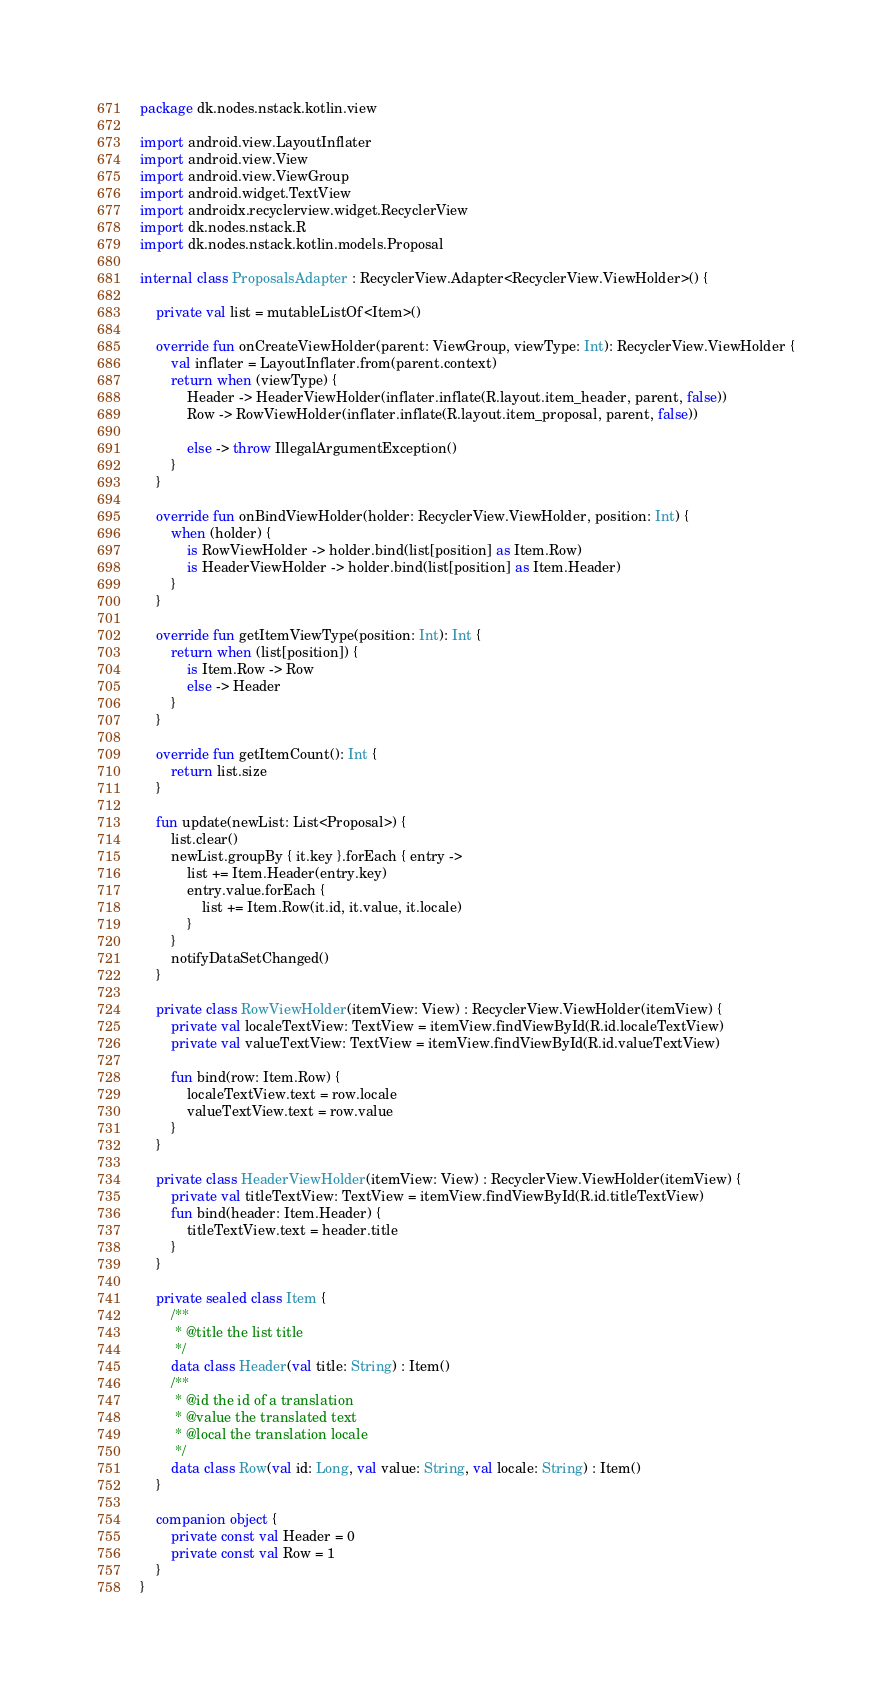Convert code to text. <code><loc_0><loc_0><loc_500><loc_500><_Kotlin_>package dk.nodes.nstack.kotlin.view

import android.view.LayoutInflater
import android.view.View
import android.view.ViewGroup
import android.widget.TextView
import androidx.recyclerview.widget.RecyclerView
import dk.nodes.nstack.R
import dk.nodes.nstack.kotlin.models.Proposal

internal class ProposalsAdapter : RecyclerView.Adapter<RecyclerView.ViewHolder>() {

    private val list = mutableListOf<Item>()

    override fun onCreateViewHolder(parent: ViewGroup, viewType: Int): RecyclerView.ViewHolder {
        val inflater = LayoutInflater.from(parent.context)
        return when (viewType) {
            Header -> HeaderViewHolder(inflater.inflate(R.layout.item_header, parent, false))
            Row -> RowViewHolder(inflater.inflate(R.layout.item_proposal, parent, false))

            else -> throw IllegalArgumentException()
        }
    }

    override fun onBindViewHolder(holder: RecyclerView.ViewHolder, position: Int) {
        when (holder) {
            is RowViewHolder -> holder.bind(list[position] as Item.Row)
            is HeaderViewHolder -> holder.bind(list[position] as Item.Header)
        }
    }

    override fun getItemViewType(position: Int): Int {
        return when (list[position]) {
            is Item.Row -> Row
            else -> Header
        }
    }

    override fun getItemCount(): Int {
        return list.size
    }

    fun update(newList: List<Proposal>) {
        list.clear()
        newList.groupBy { it.key }.forEach { entry ->
            list += Item.Header(entry.key)
            entry.value.forEach {
                list += Item.Row(it.id, it.value, it.locale)
            }
        }
        notifyDataSetChanged()
    }

    private class RowViewHolder(itemView: View) : RecyclerView.ViewHolder(itemView) {
        private val localeTextView: TextView = itemView.findViewById(R.id.localeTextView)
        private val valueTextView: TextView = itemView.findViewById(R.id.valueTextView)

        fun bind(row: Item.Row) {
            localeTextView.text = row.locale
            valueTextView.text = row.value
        }
    }

    private class HeaderViewHolder(itemView: View) : RecyclerView.ViewHolder(itemView) {
        private val titleTextView: TextView = itemView.findViewById(R.id.titleTextView)
        fun bind(header: Item.Header) {
            titleTextView.text = header.title
        }
    }

    private sealed class Item {
        /**
         * @title the list title
         */
        data class Header(val title: String) : Item()
        /**
         * @id the id of a translation
         * @value the translated text
         * @local the translation locale
         */
        data class Row(val id: Long, val value: String, val locale: String) : Item()
    }

    companion object {
        private const val Header = 0
        private const val Row = 1
    }
}
</code> 